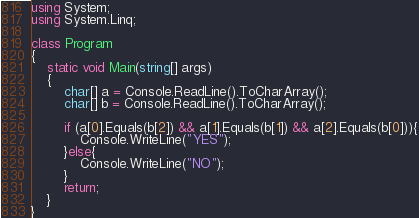Convert code to text. <code><loc_0><loc_0><loc_500><loc_500><_C#_>using System;
using System.Linq;

class Program
{
    static void Main(string[] args)
    {
        char[] a = Console.ReadLine().ToCharArray();
        char[] b = Console.ReadLine().ToCharArray();

        if (a[0].Equals(b[2]) && a[1].Equals(b[1]) && a[2].Equals(b[0])){
            Console.WriteLine("YES");
        }else{
            Console.WriteLine("NO");
        }
        return;
    }
}</code> 